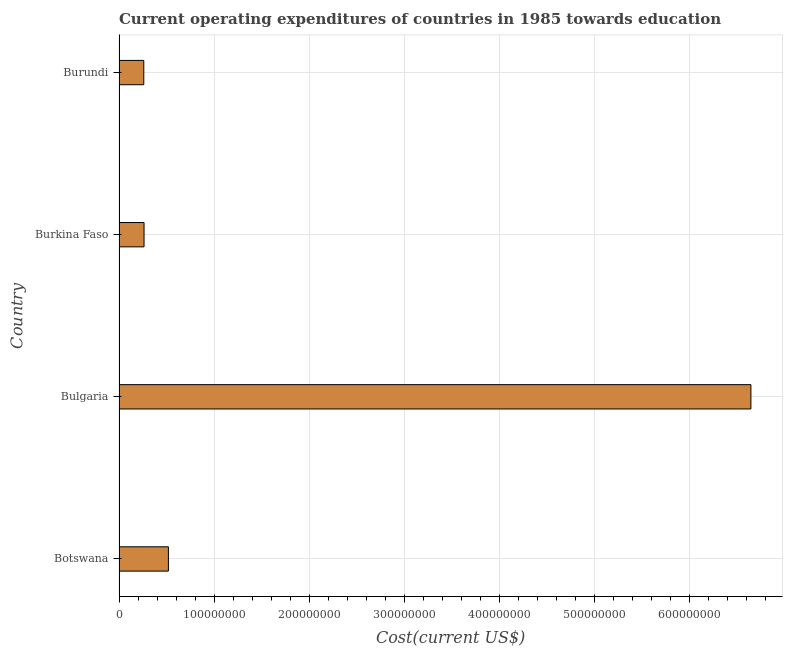What is the title of the graph?
Make the answer very short. Current operating expenditures of countries in 1985 towards education. What is the label or title of the X-axis?
Make the answer very short. Cost(current US$). What is the label or title of the Y-axis?
Your response must be concise. Country. What is the education expenditure in Bulgaria?
Keep it short and to the point. 6.65e+08. Across all countries, what is the maximum education expenditure?
Keep it short and to the point. 6.65e+08. Across all countries, what is the minimum education expenditure?
Your answer should be very brief. 2.60e+07. In which country was the education expenditure minimum?
Ensure brevity in your answer.  Burundi. What is the sum of the education expenditure?
Make the answer very short. 7.69e+08. What is the difference between the education expenditure in Botswana and Bulgaria?
Offer a very short reply. -6.13e+08. What is the average education expenditure per country?
Keep it short and to the point. 1.92e+08. What is the median education expenditure?
Your answer should be very brief. 3.91e+07. In how many countries, is the education expenditure greater than 240000000 US$?
Ensure brevity in your answer.  1. Is the education expenditure in Bulgaria less than that in Burundi?
Offer a terse response. No. What is the difference between the highest and the second highest education expenditure?
Your response must be concise. 6.13e+08. Is the sum of the education expenditure in Botswana and Burkina Faso greater than the maximum education expenditure across all countries?
Provide a short and direct response. No. What is the difference between the highest and the lowest education expenditure?
Offer a very short reply. 6.39e+08. How many bars are there?
Provide a succinct answer. 4. Are the values on the major ticks of X-axis written in scientific E-notation?
Ensure brevity in your answer.  No. What is the Cost(current US$) of Botswana?
Offer a very short reply. 5.19e+07. What is the Cost(current US$) of Bulgaria?
Give a very brief answer. 6.65e+08. What is the Cost(current US$) of Burkina Faso?
Provide a succinct answer. 2.63e+07. What is the Cost(current US$) in Burundi?
Give a very brief answer. 2.60e+07. What is the difference between the Cost(current US$) in Botswana and Bulgaria?
Provide a succinct answer. -6.13e+08. What is the difference between the Cost(current US$) in Botswana and Burkina Faso?
Your response must be concise. 2.56e+07. What is the difference between the Cost(current US$) in Botswana and Burundi?
Keep it short and to the point. 2.59e+07. What is the difference between the Cost(current US$) in Bulgaria and Burkina Faso?
Your response must be concise. 6.39e+08. What is the difference between the Cost(current US$) in Bulgaria and Burundi?
Your response must be concise. 6.39e+08. What is the difference between the Cost(current US$) in Burkina Faso and Burundi?
Give a very brief answer. 2.69e+05. What is the ratio of the Cost(current US$) in Botswana to that in Bulgaria?
Your answer should be compact. 0.08. What is the ratio of the Cost(current US$) in Botswana to that in Burkina Faso?
Keep it short and to the point. 1.98. What is the ratio of the Cost(current US$) in Botswana to that in Burundi?
Your answer should be very brief. 2. What is the ratio of the Cost(current US$) in Bulgaria to that in Burkina Faso?
Your response must be concise. 25.29. What is the ratio of the Cost(current US$) in Bulgaria to that in Burundi?
Offer a very short reply. 25.55. What is the ratio of the Cost(current US$) in Burkina Faso to that in Burundi?
Give a very brief answer. 1.01. 